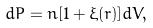Convert formula to latex. <formula><loc_0><loc_0><loc_500><loc_500>d P = n [ 1 + \xi ( r ) ] d V ,</formula> 